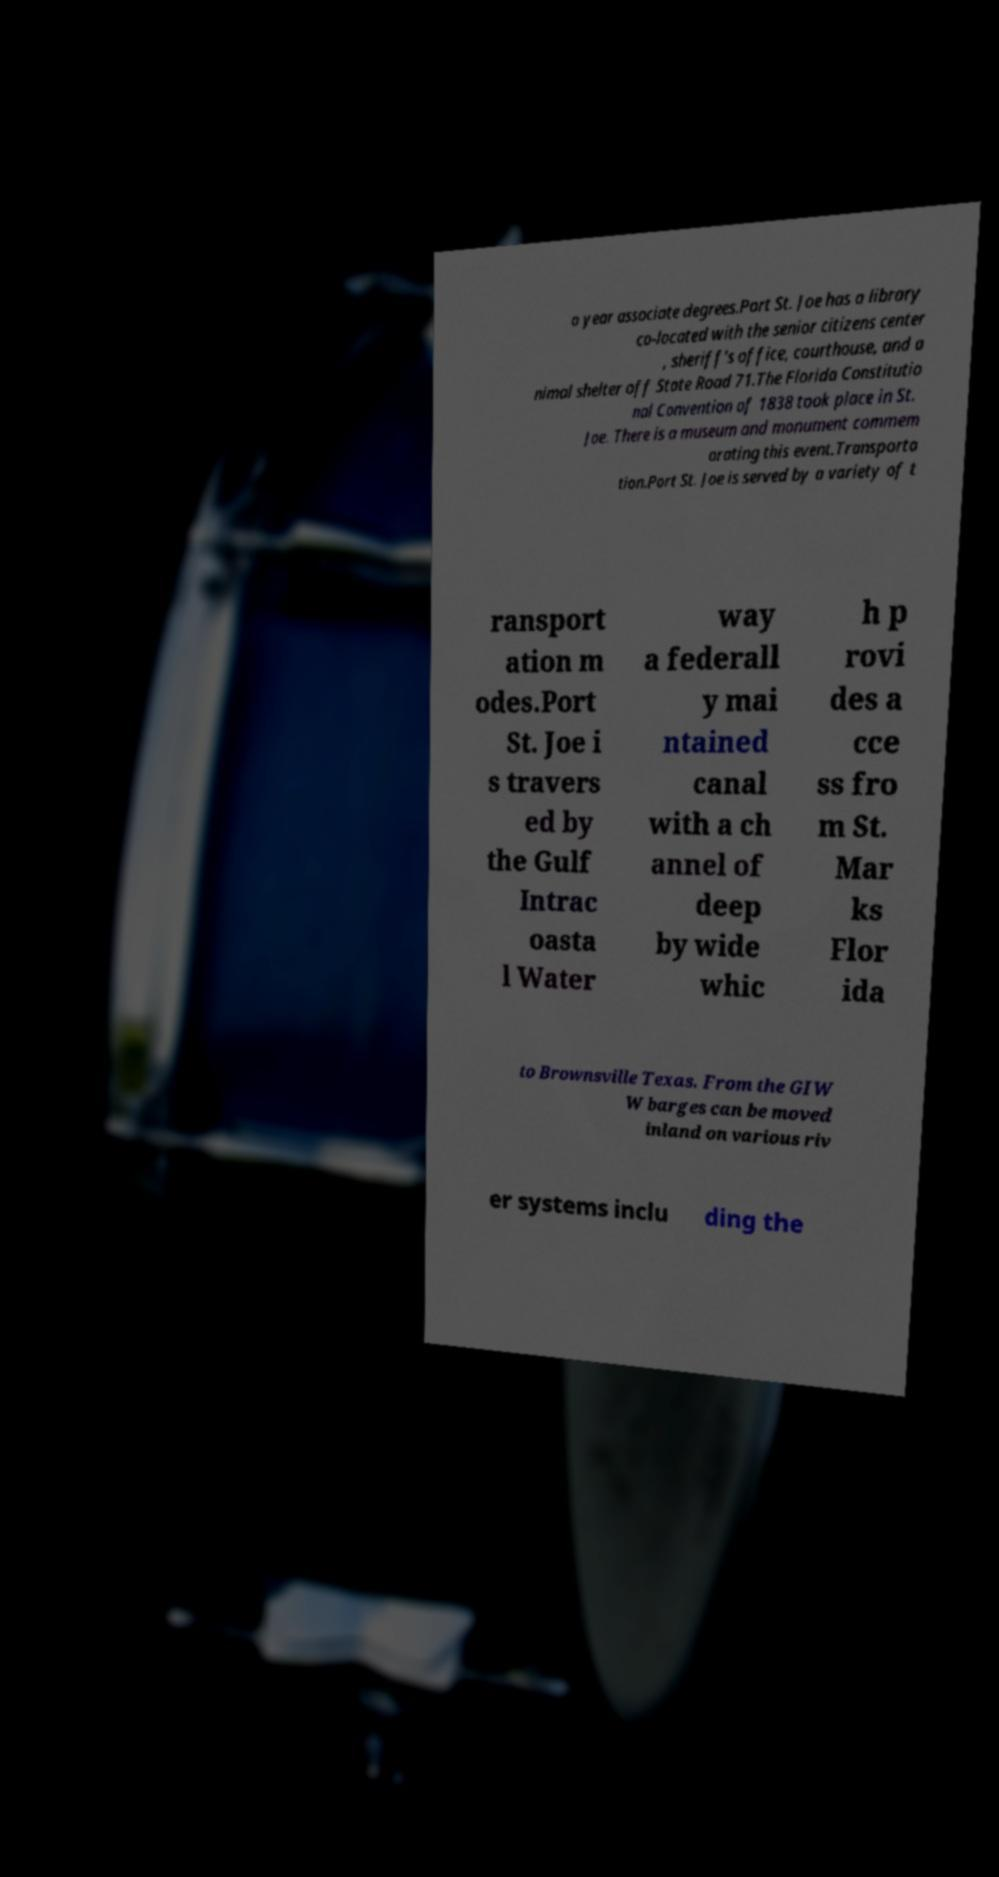Can you read and provide the text displayed in the image?This photo seems to have some interesting text. Can you extract and type it out for me? o year associate degrees.Port St. Joe has a library co-located with the senior citizens center , sheriff's office, courthouse, and a nimal shelter off State Road 71.The Florida Constitutio nal Convention of 1838 took place in St. Joe. There is a museum and monument commem orating this event.Transporta tion.Port St. Joe is served by a variety of t ransport ation m odes.Port St. Joe i s travers ed by the Gulf Intrac oasta l Water way a federall y mai ntained canal with a ch annel of deep by wide whic h p rovi des a cce ss fro m St. Mar ks Flor ida to Brownsville Texas. From the GIW W barges can be moved inland on various riv er systems inclu ding the 